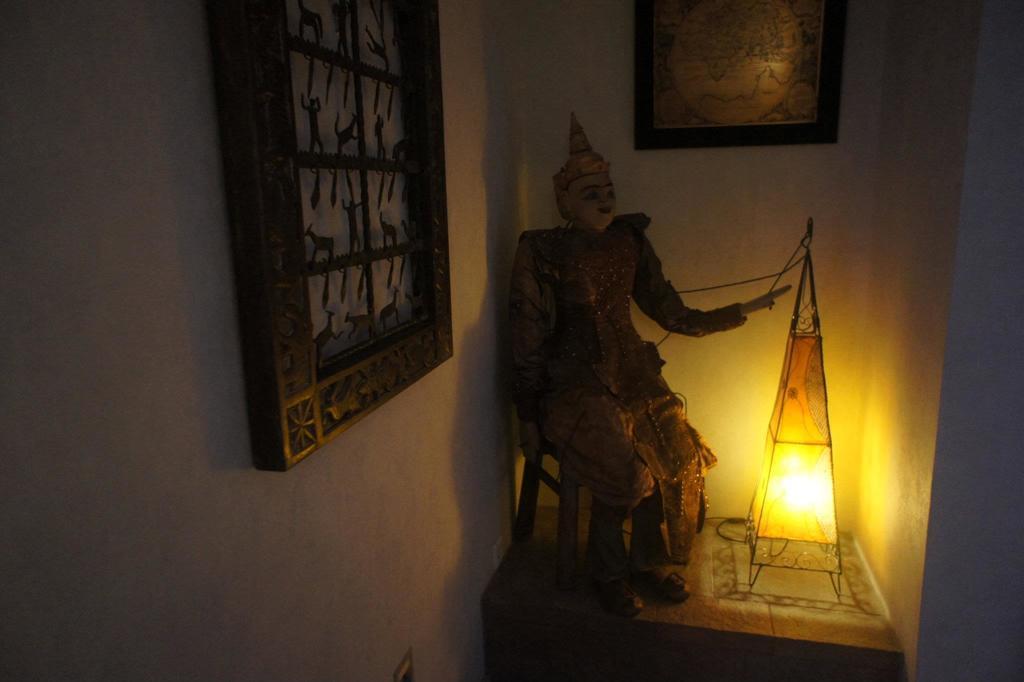In one or two sentences, can you explain what this image depicts? Here in this picture in the middle we can see a doll present on a stool over there and beside that we can see a lamp present and on the wall we can see a portrait present and we can also see a portrait on the left side of the wall over there. 